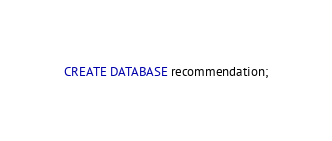<code> <loc_0><loc_0><loc_500><loc_500><_SQL_>CREATE DATABASE recommendation;
</code> 